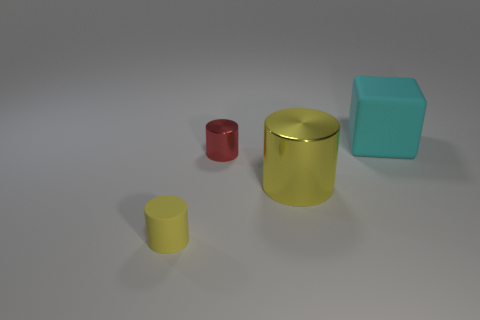What material do the objects look like they're made of? The objects in the image have a smooth and somewhat reflective surface, suggesting they could be made of a synthetic material like plastic or rubber, commonly used in 3D renderings or conceptual artwork. 